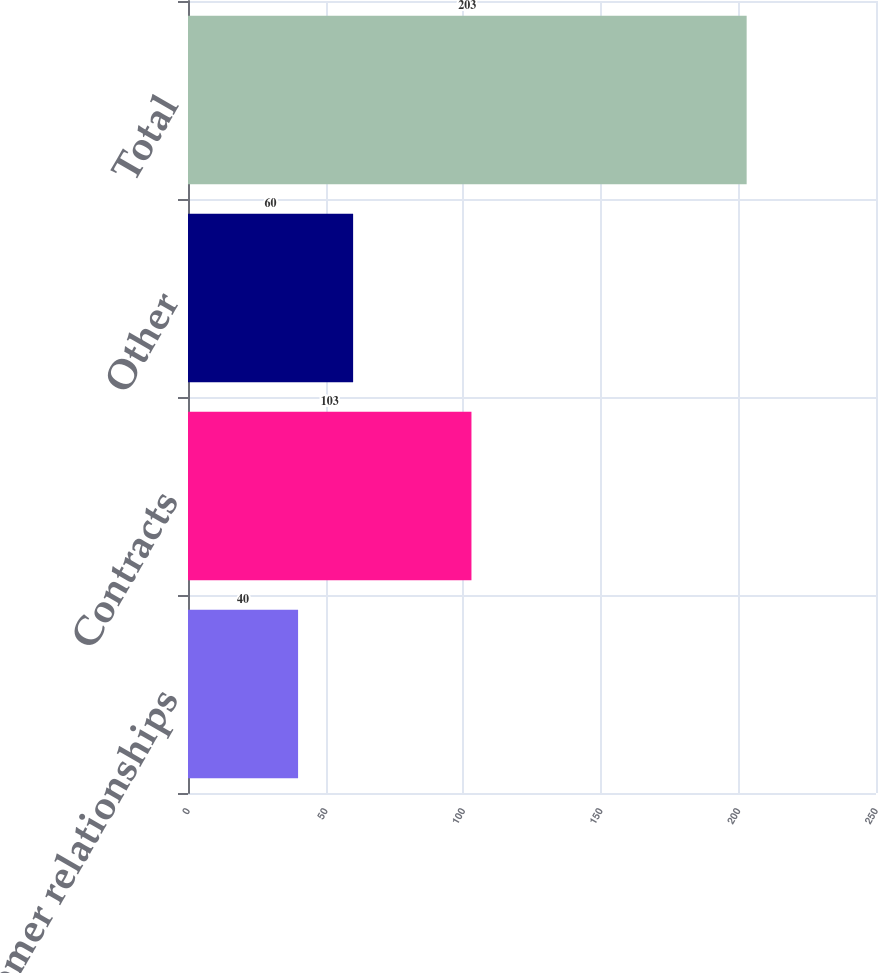Convert chart. <chart><loc_0><loc_0><loc_500><loc_500><bar_chart><fcel>Customer relationships<fcel>Contracts<fcel>Other<fcel>Total<nl><fcel>40<fcel>103<fcel>60<fcel>203<nl></chart> 